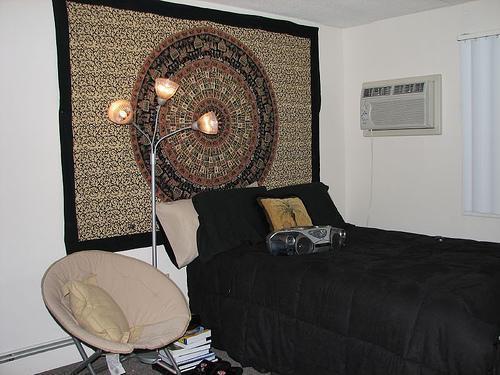How many windows?
Give a very brief answer. 1. How many brown walls are there?
Give a very brief answer. 0. 